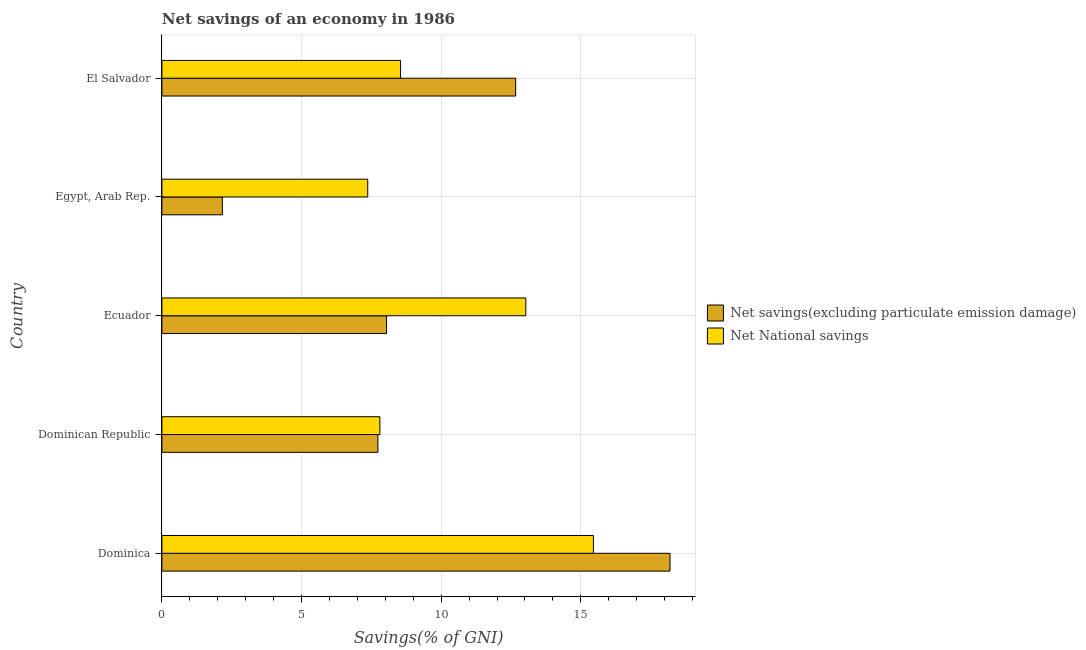How many different coloured bars are there?
Provide a succinct answer. 2. What is the label of the 4th group of bars from the top?
Your response must be concise. Dominican Republic. What is the net national savings in Egypt, Arab Rep.?
Provide a succinct answer. 7.37. Across all countries, what is the maximum net savings(excluding particulate emission damage)?
Offer a very short reply. 18.2. Across all countries, what is the minimum net savings(excluding particulate emission damage)?
Your answer should be very brief. 2.16. In which country was the net savings(excluding particulate emission damage) maximum?
Offer a very short reply. Dominica. In which country was the net national savings minimum?
Make the answer very short. Egypt, Arab Rep. What is the total net national savings in the graph?
Ensure brevity in your answer.  52.21. What is the difference between the net national savings in Dominican Republic and that in Ecuador?
Your response must be concise. -5.23. What is the difference between the net national savings in Ecuador and the net savings(excluding particulate emission damage) in Dominica?
Your response must be concise. -5.16. What is the average net national savings per country?
Make the answer very short. 10.44. What is the difference between the net national savings and net savings(excluding particulate emission damage) in Ecuador?
Offer a terse response. 4.99. In how many countries, is the net national savings greater than 13 %?
Give a very brief answer. 2. What is the ratio of the net national savings in Dominica to that in Ecuador?
Offer a terse response. 1.19. What is the difference between the highest and the second highest net national savings?
Your response must be concise. 2.42. What is the difference between the highest and the lowest net savings(excluding particulate emission damage)?
Make the answer very short. 16.03. In how many countries, is the net savings(excluding particulate emission damage) greater than the average net savings(excluding particulate emission damage) taken over all countries?
Keep it short and to the point. 2. Is the sum of the net savings(excluding particulate emission damage) in Egypt, Arab Rep. and El Salvador greater than the maximum net national savings across all countries?
Keep it short and to the point. No. What does the 1st bar from the top in Dominican Republic represents?
Ensure brevity in your answer.  Net National savings. What does the 1st bar from the bottom in Dominican Republic represents?
Offer a very short reply. Net savings(excluding particulate emission damage). Are all the bars in the graph horizontal?
Give a very brief answer. Yes. How many countries are there in the graph?
Provide a succinct answer. 5. Are the values on the major ticks of X-axis written in scientific E-notation?
Your response must be concise. No. Does the graph contain any zero values?
Give a very brief answer. No. How many legend labels are there?
Your answer should be very brief. 2. What is the title of the graph?
Provide a short and direct response. Net savings of an economy in 1986. Does "IMF nonconcessional" appear as one of the legend labels in the graph?
Provide a succinct answer. No. What is the label or title of the X-axis?
Provide a succinct answer. Savings(% of GNI). What is the Savings(% of GNI) in Net savings(excluding particulate emission damage) in Dominica?
Provide a short and direct response. 18.2. What is the Savings(% of GNI) of Net National savings in Dominica?
Ensure brevity in your answer.  15.45. What is the Savings(% of GNI) of Net savings(excluding particulate emission damage) in Dominican Republic?
Your answer should be compact. 7.74. What is the Savings(% of GNI) in Net National savings in Dominican Republic?
Provide a succinct answer. 7.81. What is the Savings(% of GNI) in Net savings(excluding particulate emission damage) in Ecuador?
Give a very brief answer. 8.05. What is the Savings(% of GNI) in Net National savings in Ecuador?
Keep it short and to the point. 13.03. What is the Savings(% of GNI) of Net savings(excluding particulate emission damage) in Egypt, Arab Rep.?
Give a very brief answer. 2.16. What is the Savings(% of GNI) of Net National savings in Egypt, Arab Rep.?
Your answer should be very brief. 7.37. What is the Savings(% of GNI) of Net savings(excluding particulate emission damage) in El Salvador?
Ensure brevity in your answer.  12.67. What is the Savings(% of GNI) of Net National savings in El Salvador?
Ensure brevity in your answer.  8.55. Across all countries, what is the maximum Savings(% of GNI) of Net savings(excluding particulate emission damage)?
Your answer should be compact. 18.2. Across all countries, what is the maximum Savings(% of GNI) in Net National savings?
Keep it short and to the point. 15.45. Across all countries, what is the minimum Savings(% of GNI) of Net savings(excluding particulate emission damage)?
Your answer should be compact. 2.16. Across all countries, what is the minimum Savings(% of GNI) of Net National savings?
Offer a terse response. 7.37. What is the total Savings(% of GNI) of Net savings(excluding particulate emission damage) in the graph?
Make the answer very short. 48.81. What is the total Savings(% of GNI) in Net National savings in the graph?
Provide a succinct answer. 52.21. What is the difference between the Savings(% of GNI) in Net savings(excluding particulate emission damage) in Dominica and that in Dominican Republic?
Provide a short and direct response. 10.46. What is the difference between the Savings(% of GNI) of Net National savings in Dominica and that in Dominican Republic?
Your answer should be compact. 7.65. What is the difference between the Savings(% of GNI) in Net savings(excluding particulate emission damage) in Dominica and that in Ecuador?
Make the answer very short. 10.15. What is the difference between the Savings(% of GNI) of Net National savings in Dominica and that in Ecuador?
Your answer should be very brief. 2.42. What is the difference between the Savings(% of GNI) of Net savings(excluding particulate emission damage) in Dominica and that in Egypt, Arab Rep.?
Keep it short and to the point. 16.03. What is the difference between the Savings(% of GNI) of Net National savings in Dominica and that in Egypt, Arab Rep.?
Offer a very short reply. 8.08. What is the difference between the Savings(% of GNI) of Net savings(excluding particulate emission damage) in Dominica and that in El Salvador?
Offer a very short reply. 5.53. What is the difference between the Savings(% of GNI) in Net National savings in Dominica and that in El Salvador?
Provide a succinct answer. 6.91. What is the difference between the Savings(% of GNI) of Net savings(excluding particulate emission damage) in Dominican Republic and that in Ecuador?
Give a very brief answer. -0.31. What is the difference between the Savings(% of GNI) of Net National savings in Dominican Republic and that in Ecuador?
Offer a very short reply. -5.23. What is the difference between the Savings(% of GNI) of Net savings(excluding particulate emission damage) in Dominican Republic and that in Egypt, Arab Rep.?
Your answer should be very brief. 5.57. What is the difference between the Savings(% of GNI) of Net National savings in Dominican Republic and that in Egypt, Arab Rep.?
Your answer should be compact. 0.43. What is the difference between the Savings(% of GNI) in Net savings(excluding particulate emission damage) in Dominican Republic and that in El Salvador?
Give a very brief answer. -4.93. What is the difference between the Savings(% of GNI) of Net National savings in Dominican Republic and that in El Salvador?
Make the answer very short. -0.74. What is the difference between the Savings(% of GNI) of Net savings(excluding particulate emission damage) in Ecuador and that in Egypt, Arab Rep.?
Offer a very short reply. 5.88. What is the difference between the Savings(% of GNI) in Net National savings in Ecuador and that in Egypt, Arab Rep.?
Offer a terse response. 5.66. What is the difference between the Savings(% of GNI) of Net savings(excluding particulate emission damage) in Ecuador and that in El Salvador?
Your response must be concise. -4.62. What is the difference between the Savings(% of GNI) in Net National savings in Ecuador and that in El Salvador?
Your answer should be very brief. 4.48. What is the difference between the Savings(% of GNI) in Net savings(excluding particulate emission damage) in Egypt, Arab Rep. and that in El Salvador?
Ensure brevity in your answer.  -10.5. What is the difference between the Savings(% of GNI) of Net National savings in Egypt, Arab Rep. and that in El Salvador?
Give a very brief answer. -1.18. What is the difference between the Savings(% of GNI) in Net savings(excluding particulate emission damage) in Dominica and the Savings(% of GNI) in Net National savings in Dominican Republic?
Keep it short and to the point. 10.39. What is the difference between the Savings(% of GNI) of Net savings(excluding particulate emission damage) in Dominica and the Savings(% of GNI) of Net National savings in Ecuador?
Offer a very short reply. 5.16. What is the difference between the Savings(% of GNI) of Net savings(excluding particulate emission damage) in Dominica and the Savings(% of GNI) of Net National savings in Egypt, Arab Rep.?
Offer a terse response. 10.82. What is the difference between the Savings(% of GNI) in Net savings(excluding particulate emission damage) in Dominica and the Savings(% of GNI) in Net National savings in El Salvador?
Your answer should be compact. 9.65. What is the difference between the Savings(% of GNI) in Net savings(excluding particulate emission damage) in Dominican Republic and the Savings(% of GNI) in Net National savings in Ecuador?
Ensure brevity in your answer.  -5.3. What is the difference between the Savings(% of GNI) of Net savings(excluding particulate emission damage) in Dominican Republic and the Savings(% of GNI) of Net National savings in Egypt, Arab Rep.?
Keep it short and to the point. 0.36. What is the difference between the Savings(% of GNI) of Net savings(excluding particulate emission damage) in Dominican Republic and the Savings(% of GNI) of Net National savings in El Salvador?
Your answer should be compact. -0.81. What is the difference between the Savings(% of GNI) in Net savings(excluding particulate emission damage) in Ecuador and the Savings(% of GNI) in Net National savings in Egypt, Arab Rep.?
Offer a very short reply. 0.67. What is the difference between the Savings(% of GNI) of Net savings(excluding particulate emission damage) in Ecuador and the Savings(% of GNI) of Net National savings in El Salvador?
Keep it short and to the point. -0.5. What is the difference between the Savings(% of GNI) of Net savings(excluding particulate emission damage) in Egypt, Arab Rep. and the Savings(% of GNI) of Net National savings in El Salvador?
Keep it short and to the point. -6.38. What is the average Savings(% of GNI) of Net savings(excluding particulate emission damage) per country?
Provide a succinct answer. 9.76. What is the average Savings(% of GNI) of Net National savings per country?
Give a very brief answer. 10.44. What is the difference between the Savings(% of GNI) of Net savings(excluding particulate emission damage) and Savings(% of GNI) of Net National savings in Dominica?
Keep it short and to the point. 2.74. What is the difference between the Savings(% of GNI) in Net savings(excluding particulate emission damage) and Savings(% of GNI) in Net National savings in Dominican Republic?
Ensure brevity in your answer.  -0.07. What is the difference between the Savings(% of GNI) in Net savings(excluding particulate emission damage) and Savings(% of GNI) in Net National savings in Ecuador?
Offer a terse response. -4.99. What is the difference between the Savings(% of GNI) of Net savings(excluding particulate emission damage) and Savings(% of GNI) of Net National savings in Egypt, Arab Rep.?
Offer a very short reply. -5.21. What is the difference between the Savings(% of GNI) of Net savings(excluding particulate emission damage) and Savings(% of GNI) of Net National savings in El Salvador?
Keep it short and to the point. 4.12. What is the ratio of the Savings(% of GNI) in Net savings(excluding particulate emission damage) in Dominica to that in Dominican Republic?
Offer a terse response. 2.35. What is the ratio of the Savings(% of GNI) of Net National savings in Dominica to that in Dominican Republic?
Offer a very short reply. 1.98. What is the ratio of the Savings(% of GNI) of Net savings(excluding particulate emission damage) in Dominica to that in Ecuador?
Your response must be concise. 2.26. What is the ratio of the Savings(% of GNI) in Net National savings in Dominica to that in Ecuador?
Give a very brief answer. 1.19. What is the ratio of the Savings(% of GNI) of Net savings(excluding particulate emission damage) in Dominica to that in Egypt, Arab Rep.?
Offer a very short reply. 8.41. What is the ratio of the Savings(% of GNI) in Net National savings in Dominica to that in Egypt, Arab Rep.?
Make the answer very short. 2.1. What is the ratio of the Savings(% of GNI) in Net savings(excluding particulate emission damage) in Dominica to that in El Salvador?
Ensure brevity in your answer.  1.44. What is the ratio of the Savings(% of GNI) of Net National savings in Dominica to that in El Salvador?
Make the answer very short. 1.81. What is the ratio of the Savings(% of GNI) in Net savings(excluding particulate emission damage) in Dominican Republic to that in Ecuador?
Offer a terse response. 0.96. What is the ratio of the Savings(% of GNI) in Net National savings in Dominican Republic to that in Ecuador?
Your answer should be very brief. 0.6. What is the ratio of the Savings(% of GNI) in Net savings(excluding particulate emission damage) in Dominican Republic to that in Egypt, Arab Rep.?
Provide a short and direct response. 3.57. What is the ratio of the Savings(% of GNI) of Net National savings in Dominican Republic to that in Egypt, Arab Rep.?
Offer a terse response. 1.06. What is the ratio of the Savings(% of GNI) of Net savings(excluding particulate emission damage) in Dominican Republic to that in El Salvador?
Offer a very short reply. 0.61. What is the ratio of the Savings(% of GNI) in Net National savings in Dominican Republic to that in El Salvador?
Keep it short and to the point. 0.91. What is the ratio of the Savings(% of GNI) of Net savings(excluding particulate emission damage) in Ecuador to that in Egypt, Arab Rep.?
Your answer should be compact. 3.72. What is the ratio of the Savings(% of GNI) of Net National savings in Ecuador to that in Egypt, Arab Rep.?
Keep it short and to the point. 1.77. What is the ratio of the Savings(% of GNI) of Net savings(excluding particulate emission damage) in Ecuador to that in El Salvador?
Your answer should be very brief. 0.64. What is the ratio of the Savings(% of GNI) in Net National savings in Ecuador to that in El Salvador?
Ensure brevity in your answer.  1.52. What is the ratio of the Savings(% of GNI) of Net savings(excluding particulate emission damage) in Egypt, Arab Rep. to that in El Salvador?
Your answer should be very brief. 0.17. What is the ratio of the Savings(% of GNI) of Net National savings in Egypt, Arab Rep. to that in El Salvador?
Your answer should be very brief. 0.86. What is the difference between the highest and the second highest Savings(% of GNI) in Net savings(excluding particulate emission damage)?
Provide a succinct answer. 5.53. What is the difference between the highest and the second highest Savings(% of GNI) in Net National savings?
Keep it short and to the point. 2.42. What is the difference between the highest and the lowest Savings(% of GNI) in Net savings(excluding particulate emission damage)?
Your response must be concise. 16.03. What is the difference between the highest and the lowest Savings(% of GNI) of Net National savings?
Provide a short and direct response. 8.08. 